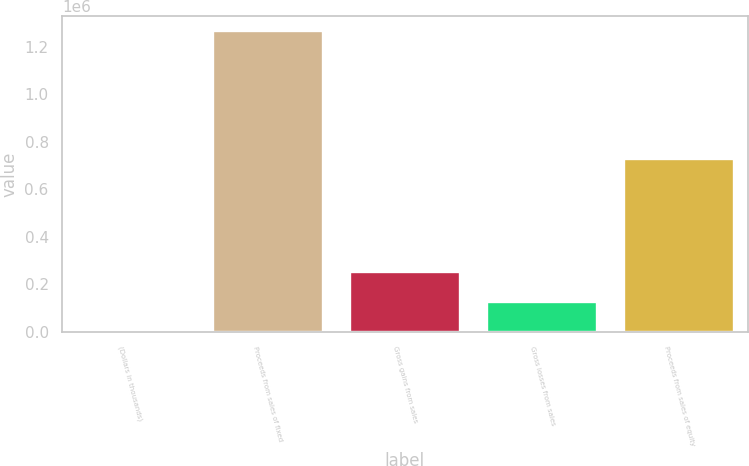Convert chart. <chart><loc_0><loc_0><loc_500><loc_500><bar_chart><fcel>(Dollars in thousands)<fcel>Proceeds from sales of fixed<fcel>Gross gains from sales<fcel>Gross losses from sales<fcel>Proceeds from sales of equity<nl><fcel>2016<fcel>1.26427e+06<fcel>254467<fcel>128242<fcel>729782<nl></chart> 